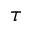<formula> <loc_0><loc_0><loc_500><loc_500>\tau</formula> 